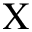Convert formula to latex. <formula><loc_0><loc_0><loc_500><loc_500>\chi</formula> 